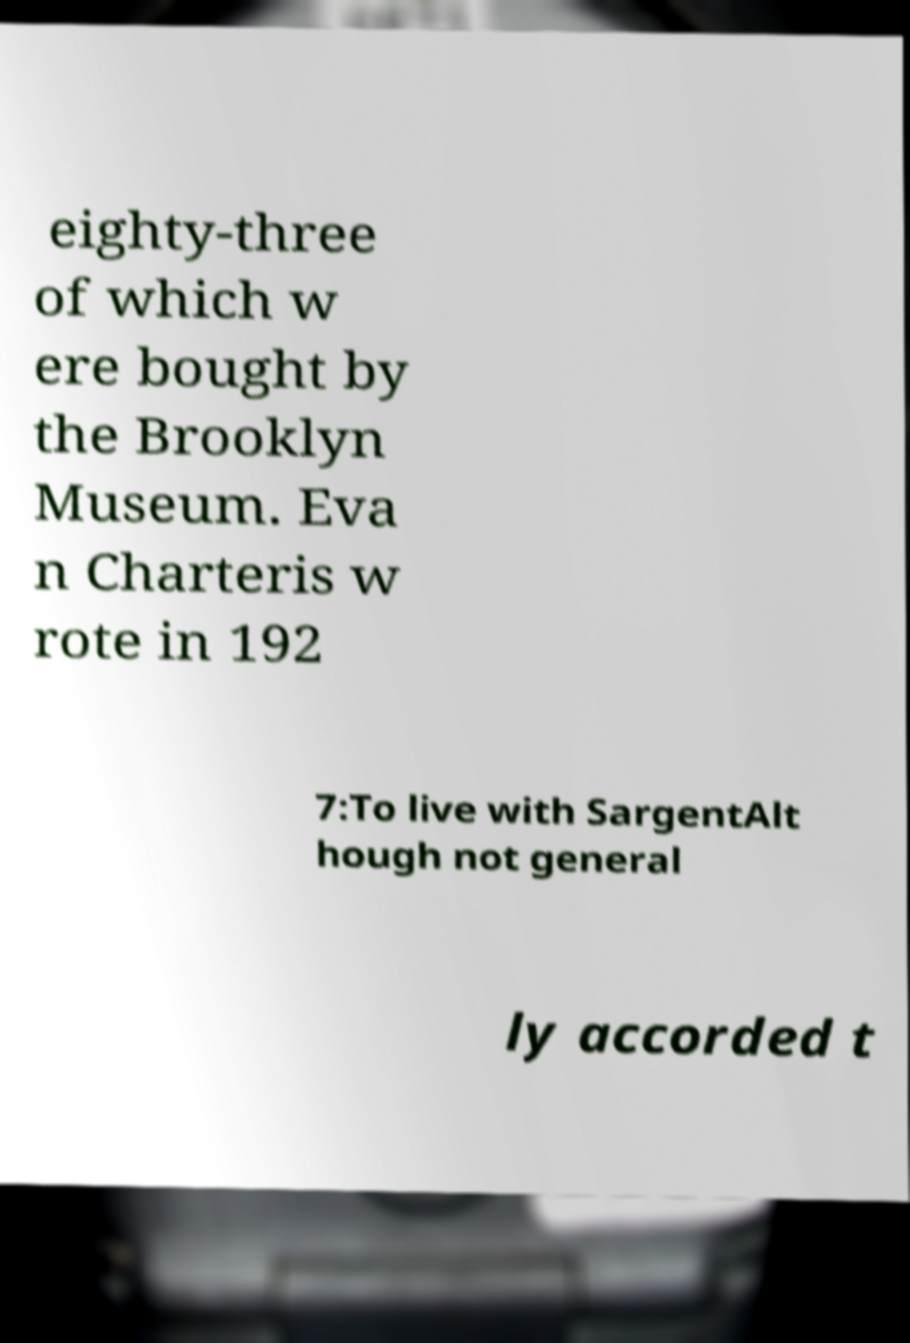There's text embedded in this image that I need extracted. Can you transcribe it verbatim? eighty-three of which w ere bought by the Brooklyn Museum. Eva n Charteris w rote in 192 7:To live with SargentAlt hough not general ly accorded t 